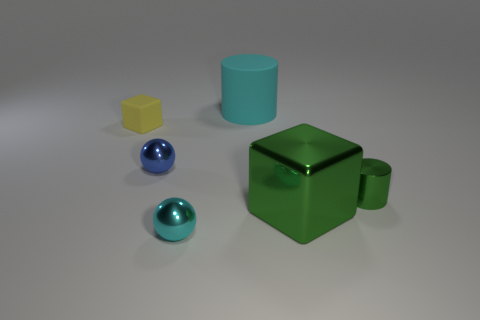Does the tiny cyan object have the same shape as the small green thing?
Offer a terse response. No. There is a cyan object that is the same shape as the small blue thing; what material is it?
Ensure brevity in your answer.  Metal. There is a thing that is behind the tiny blue shiny thing and on the right side of the tiny matte object; what color is it?
Offer a very short reply. Cyan. The tiny rubber cube has what color?
Make the answer very short. Yellow. There is a large thing that is the same color as the tiny cylinder; what is its material?
Offer a terse response. Metal. Is there a large shiny thing that has the same shape as the small rubber thing?
Your answer should be compact. Yes. There is a cyan object that is in front of the matte cylinder; how big is it?
Offer a terse response. Small. There is a blue object that is the same size as the metallic cylinder; what is its material?
Provide a short and direct response. Metal. Are there more tiny cyan metal spheres than cylinders?
Provide a short and direct response. No. How big is the shiny sphere that is on the right side of the sphere behind the tiny cyan metal object?
Ensure brevity in your answer.  Small. 